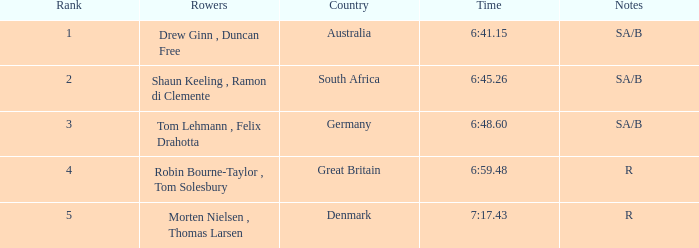What was the top position achieved by danish rowers? 5.0. 